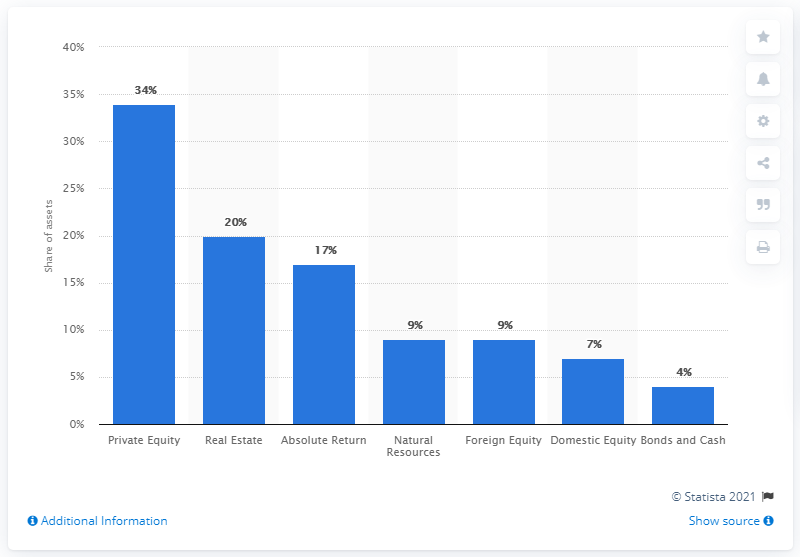Identify some key points in this picture. Approximately 34% of Yale's endowment fund is accounted for by private equity. 